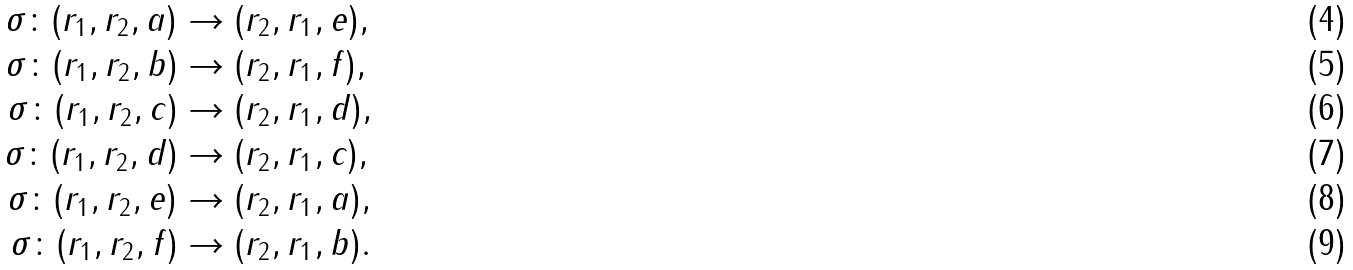<formula> <loc_0><loc_0><loc_500><loc_500>\sigma \colon ( r _ { 1 } , r _ { 2 } , a ) & \rightarrow ( r _ { 2 } , r _ { 1 } , e ) , \\ \sigma \colon ( r _ { 1 } , r _ { 2 } , b ) & \rightarrow ( r _ { 2 } , r _ { 1 } , f ) , \\ \sigma \colon ( r _ { 1 } , r _ { 2 } , c ) & \rightarrow ( r _ { 2 } , r _ { 1 } , d ) , \\ \sigma \colon ( r _ { 1 } , r _ { 2 } , d ) & \rightarrow ( r _ { 2 } , r _ { 1 } , c ) , \\ \sigma \colon ( r _ { 1 } , r _ { 2 } , e ) & \rightarrow ( r _ { 2 } , r _ { 1 } , a ) , \\ \sigma \colon ( r _ { 1 } , r _ { 2 } , f ) & \rightarrow ( r _ { 2 } , r _ { 1 } , b ) .</formula> 